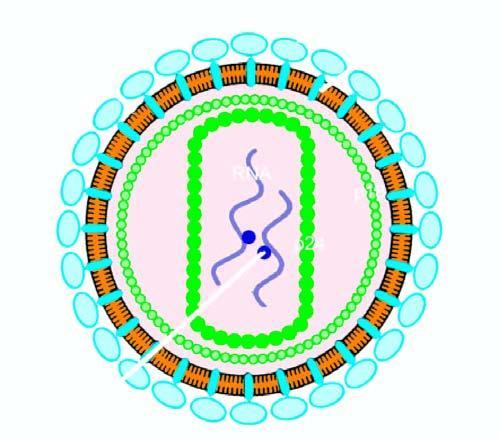s bilayer lipid membrane studded with 2 viral glycoproteins, gp120 and gp41, in the positions shown?
Answer the question using a single word or phrase. Yes 